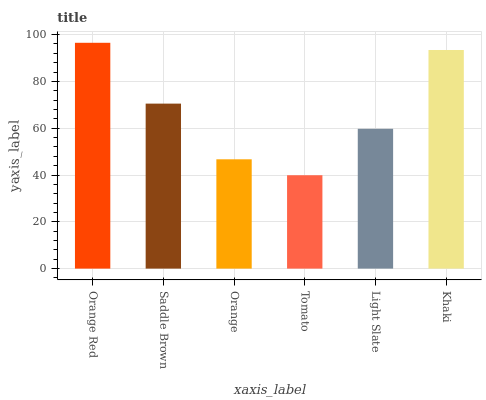Is Tomato the minimum?
Answer yes or no. Yes. Is Orange Red the maximum?
Answer yes or no. Yes. Is Saddle Brown the minimum?
Answer yes or no. No. Is Saddle Brown the maximum?
Answer yes or no. No. Is Orange Red greater than Saddle Brown?
Answer yes or no. Yes. Is Saddle Brown less than Orange Red?
Answer yes or no. Yes. Is Saddle Brown greater than Orange Red?
Answer yes or no. No. Is Orange Red less than Saddle Brown?
Answer yes or no. No. Is Saddle Brown the high median?
Answer yes or no. Yes. Is Light Slate the low median?
Answer yes or no. Yes. Is Light Slate the high median?
Answer yes or no. No. Is Khaki the low median?
Answer yes or no. No. 